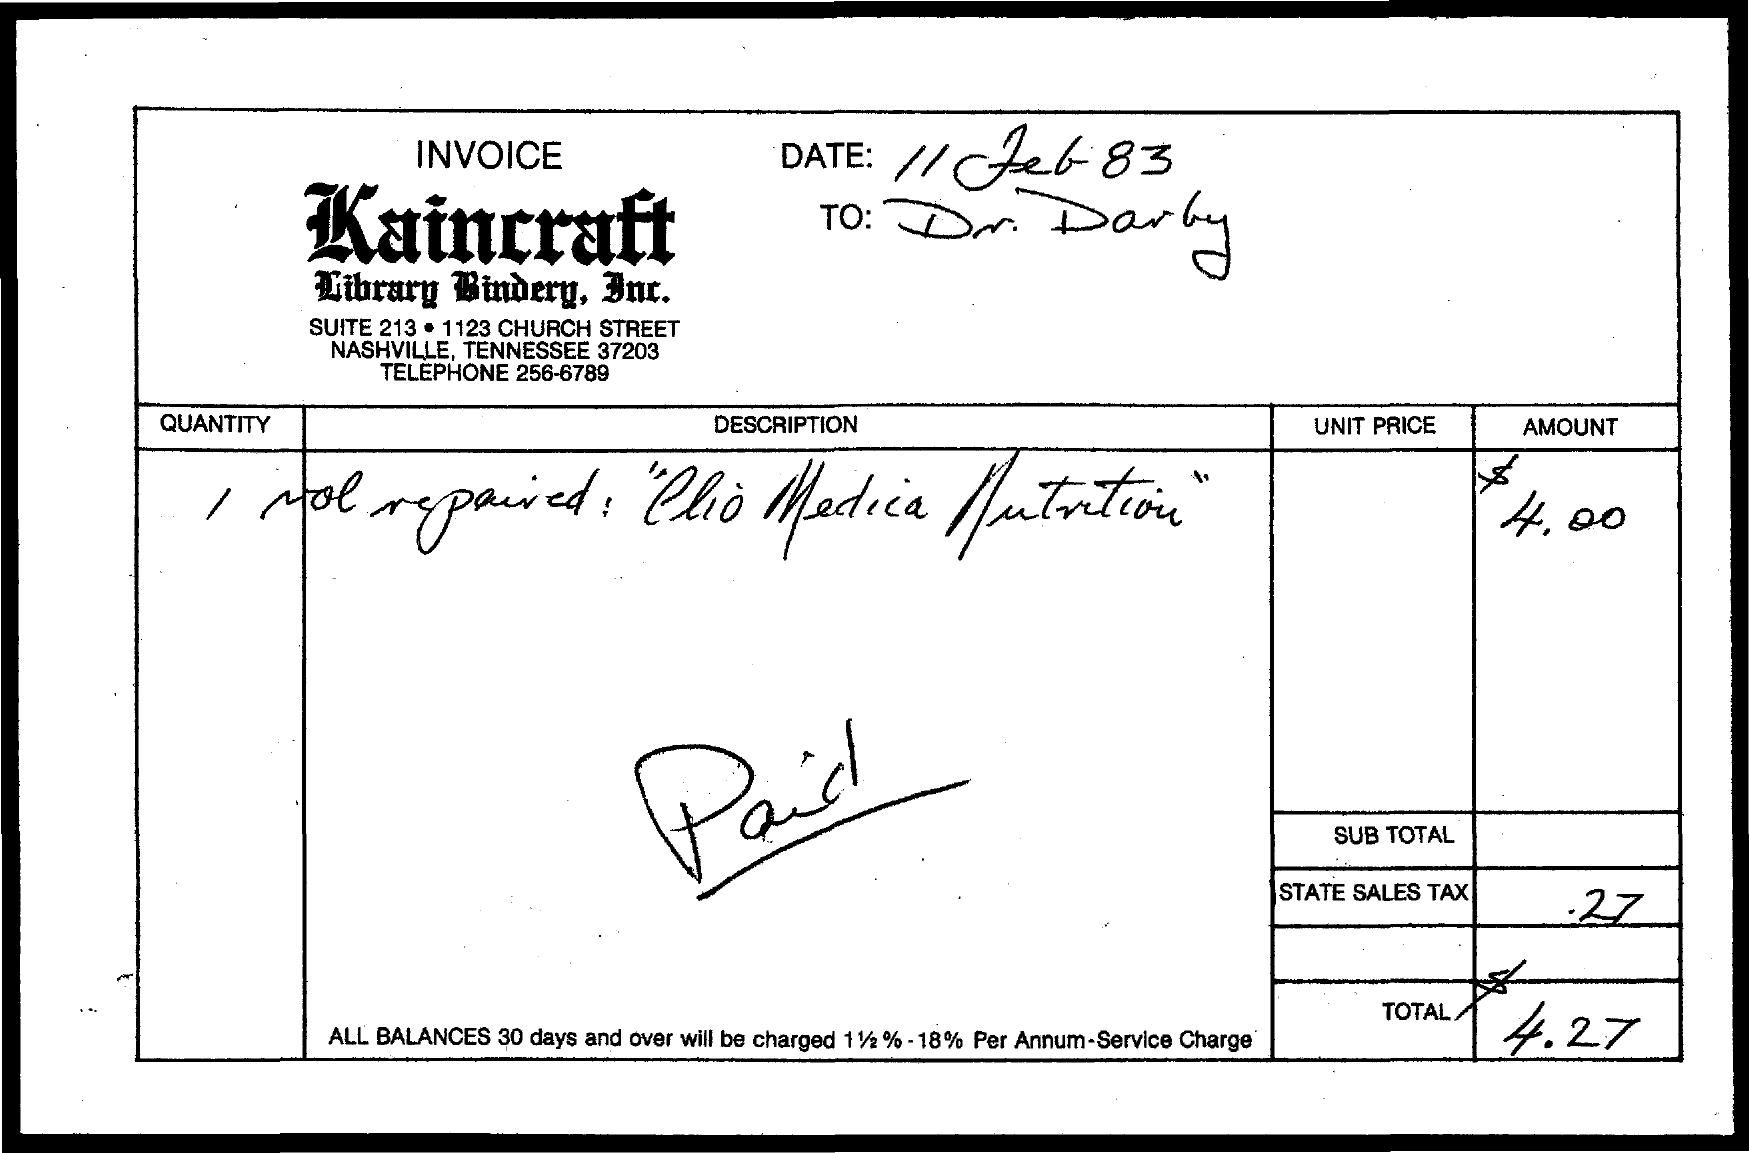What is the State Sales Tax?
Your answer should be very brief. .27. What is the date mentioned in the document?
Give a very brief answer. 11 feb 83. What is the total amount?
Keep it short and to the point. $ 4.27. 